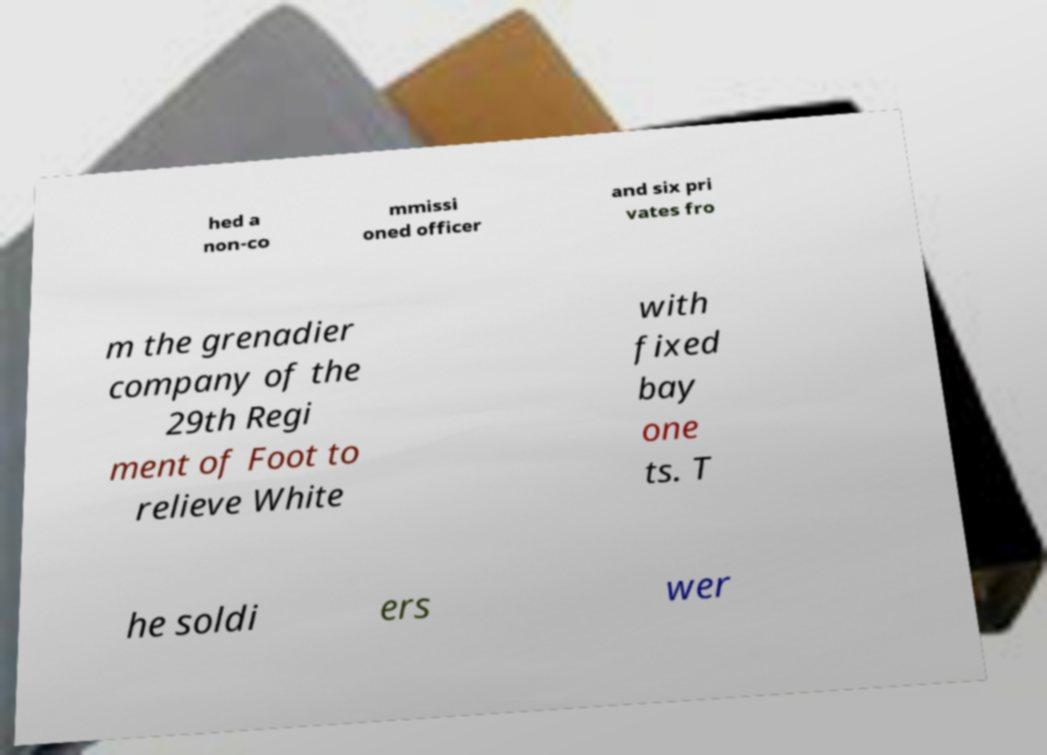Could you assist in decoding the text presented in this image and type it out clearly? hed a non-co mmissi oned officer and six pri vates fro m the grenadier company of the 29th Regi ment of Foot to relieve White with fixed bay one ts. T he soldi ers wer 